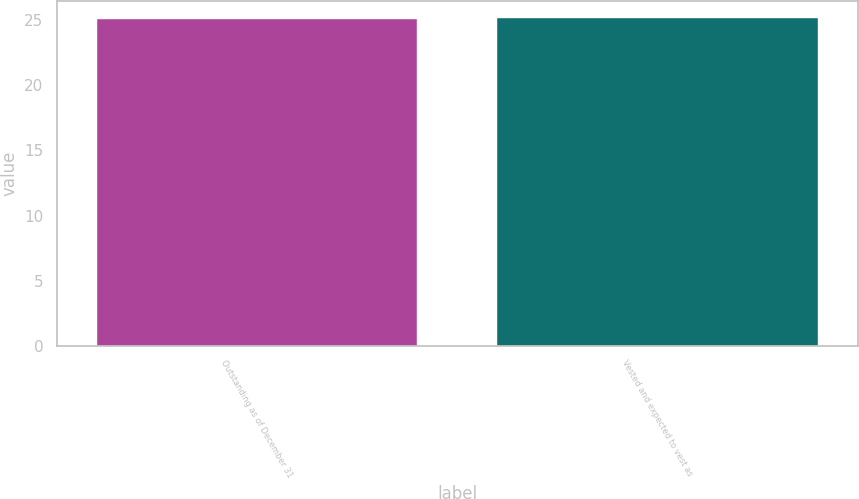Convert chart to OTSL. <chart><loc_0><loc_0><loc_500><loc_500><bar_chart><fcel>Outstanding as of December 31<fcel>Vested and expected to vest as<nl><fcel>25.1<fcel>25.2<nl></chart> 